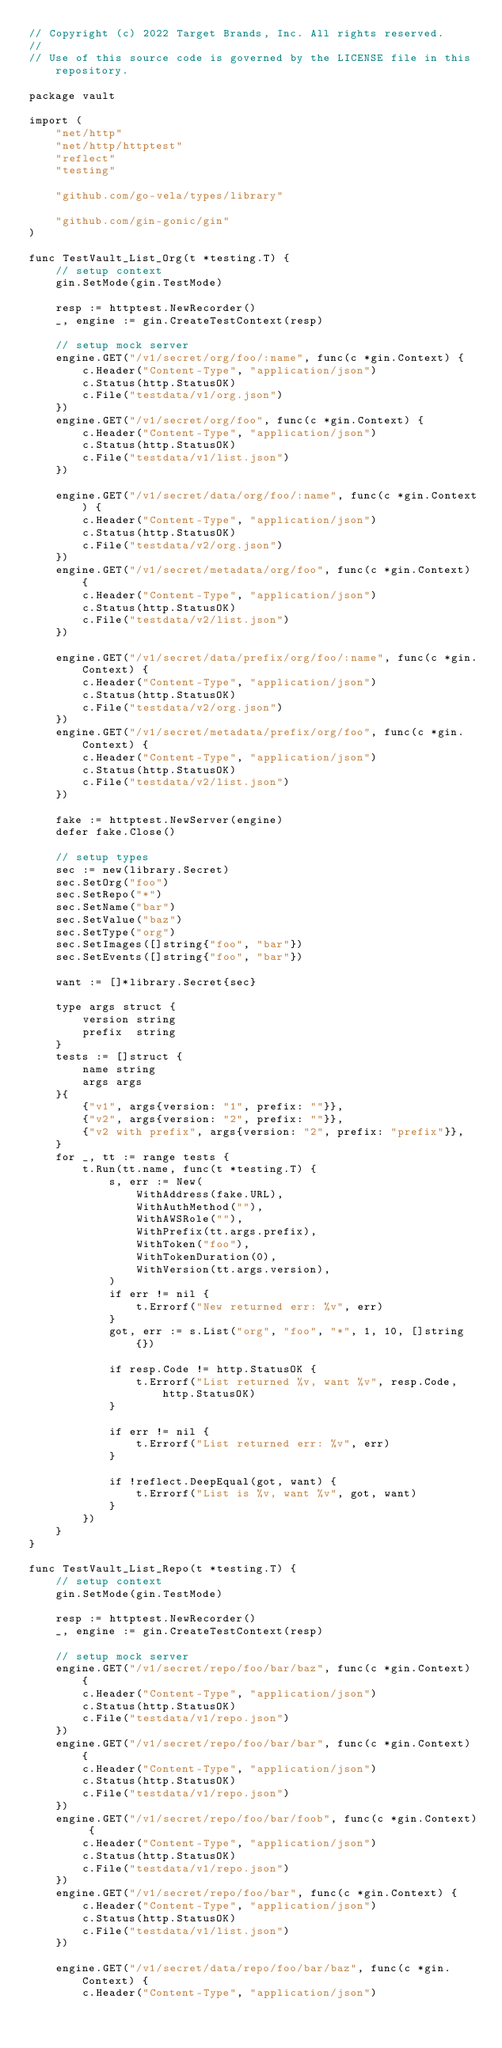<code> <loc_0><loc_0><loc_500><loc_500><_Go_>// Copyright (c) 2022 Target Brands, Inc. All rights reserved.
//
// Use of this source code is governed by the LICENSE file in this repository.

package vault

import (
	"net/http"
	"net/http/httptest"
	"reflect"
	"testing"

	"github.com/go-vela/types/library"

	"github.com/gin-gonic/gin"
)

func TestVault_List_Org(t *testing.T) {
	// setup context
	gin.SetMode(gin.TestMode)

	resp := httptest.NewRecorder()
	_, engine := gin.CreateTestContext(resp)

	// setup mock server
	engine.GET("/v1/secret/org/foo/:name", func(c *gin.Context) {
		c.Header("Content-Type", "application/json")
		c.Status(http.StatusOK)
		c.File("testdata/v1/org.json")
	})
	engine.GET("/v1/secret/org/foo", func(c *gin.Context) {
		c.Header("Content-Type", "application/json")
		c.Status(http.StatusOK)
		c.File("testdata/v1/list.json")
	})

	engine.GET("/v1/secret/data/org/foo/:name", func(c *gin.Context) {
		c.Header("Content-Type", "application/json")
		c.Status(http.StatusOK)
		c.File("testdata/v2/org.json")
	})
	engine.GET("/v1/secret/metadata/org/foo", func(c *gin.Context) {
		c.Header("Content-Type", "application/json")
		c.Status(http.StatusOK)
		c.File("testdata/v2/list.json")
	})

	engine.GET("/v1/secret/data/prefix/org/foo/:name", func(c *gin.Context) {
		c.Header("Content-Type", "application/json")
		c.Status(http.StatusOK)
		c.File("testdata/v2/org.json")
	})
	engine.GET("/v1/secret/metadata/prefix/org/foo", func(c *gin.Context) {
		c.Header("Content-Type", "application/json")
		c.Status(http.StatusOK)
		c.File("testdata/v2/list.json")
	})

	fake := httptest.NewServer(engine)
	defer fake.Close()

	// setup types
	sec := new(library.Secret)
	sec.SetOrg("foo")
	sec.SetRepo("*")
	sec.SetName("bar")
	sec.SetValue("baz")
	sec.SetType("org")
	sec.SetImages([]string{"foo", "bar"})
	sec.SetEvents([]string{"foo", "bar"})

	want := []*library.Secret{sec}

	type args struct {
		version string
		prefix  string
	}
	tests := []struct {
		name string
		args args
	}{
		{"v1", args{version: "1", prefix: ""}},
		{"v2", args{version: "2", prefix: ""}},
		{"v2 with prefix", args{version: "2", prefix: "prefix"}},
	}
	for _, tt := range tests {
		t.Run(tt.name, func(t *testing.T) {
			s, err := New(
				WithAddress(fake.URL),
				WithAuthMethod(""),
				WithAWSRole(""),
				WithPrefix(tt.args.prefix),
				WithToken("foo"),
				WithTokenDuration(0),
				WithVersion(tt.args.version),
			)
			if err != nil {
				t.Errorf("New returned err: %v", err)
			}
			got, err := s.List("org", "foo", "*", 1, 10, []string{})

			if resp.Code != http.StatusOK {
				t.Errorf("List returned %v, want %v", resp.Code, http.StatusOK)
			}

			if err != nil {
				t.Errorf("List returned err: %v", err)
			}

			if !reflect.DeepEqual(got, want) {
				t.Errorf("List is %v, want %v", got, want)
			}
		})
	}
}

func TestVault_List_Repo(t *testing.T) {
	// setup context
	gin.SetMode(gin.TestMode)

	resp := httptest.NewRecorder()
	_, engine := gin.CreateTestContext(resp)

	// setup mock server
	engine.GET("/v1/secret/repo/foo/bar/baz", func(c *gin.Context) {
		c.Header("Content-Type", "application/json")
		c.Status(http.StatusOK)
		c.File("testdata/v1/repo.json")
	})
	engine.GET("/v1/secret/repo/foo/bar/bar", func(c *gin.Context) {
		c.Header("Content-Type", "application/json")
		c.Status(http.StatusOK)
		c.File("testdata/v1/repo.json")
	})
	engine.GET("/v1/secret/repo/foo/bar/foob", func(c *gin.Context) {
		c.Header("Content-Type", "application/json")
		c.Status(http.StatusOK)
		c.File("testdata/v1/repo.json")
	})
	engine.GET("/v1/secret/repo/foo/bar", func(c *gin.Context) {
		c.Header("Content-Type", "application/json")
		c.Status(http.StatusOK)
		c.File("testdata/v1/list.json")
	})

	engine.GET("/v1/secret/data/repo/foo/bar/baz", func(c *gin.Context) {
		c.Header("Content-Type", "application/json")</code> 